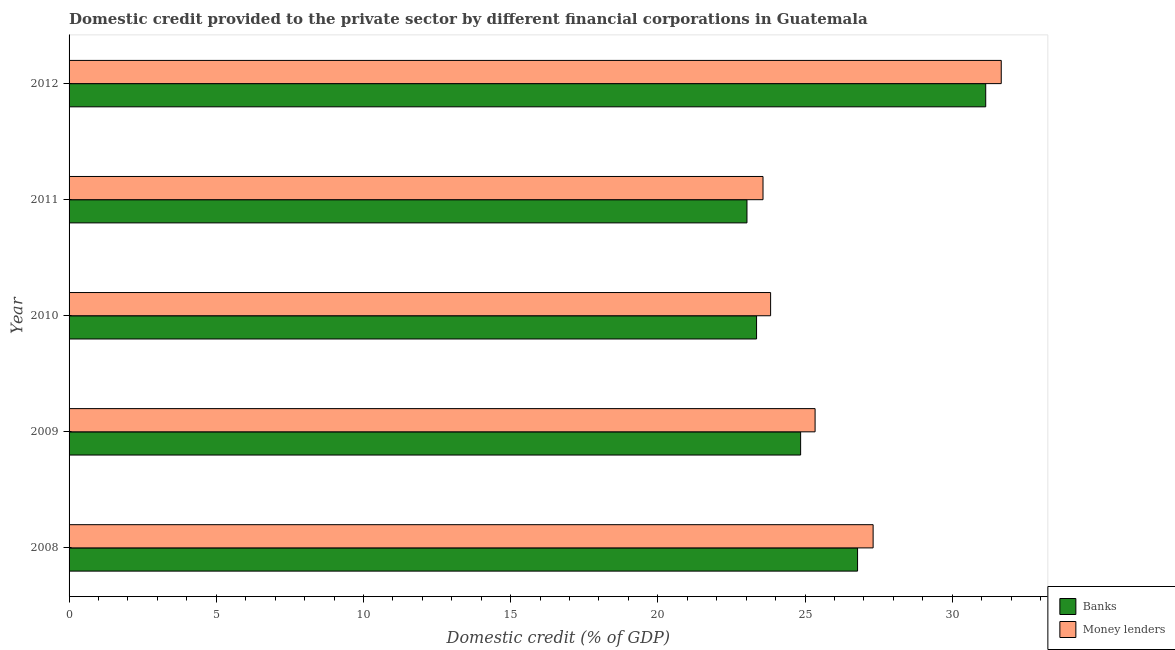How many different coloured bars are there?
Offer a terse response. 2. How many groups of bars are there?
Your answer should be very brief. 5. How many bars are there on the 1st tick from the bottom?
Your answer should be very brief. 2. What is the label of the 2nd group of bars from the top?
Your answer should be very brief. 2011. What is the domestic credit provided by banks in 2009?
Your answer should be very brief. 24.85. Across all years, what is the maximum domestic credit provided by banks?
Keep it short and to the point. 31.14. Across all years, what is the minimum domestic credit provided by money lenders?
Provide a short and direct response. 23.57. What is the total domestic credit provided by money lenders in the graph?
Your answer should be very brief. 131.72. What is the difference between the domestic credit provided by money lenders in 2011 and that in 2012?
Make the answer very short. -8.09. What is the difference between the domestic credit provided by banks in 2012 and the domestic credit provided by money lenders in 2009?
Provide a short and direct response. 5.8. What is the average domestic credit provided by banks per year?
Your response must be concise. 25.83. In the year 2009, what is the difference between the domestic credit provided by money lenders and domestic credit provided by banks?
Offer a very short reply. 0.49. In how many years, is the domestic credit provided by banks greater than 20 %?
Ensure brevity in your answer.  5. What is the ratio of the domestic credit provided by banks in 2008 to that in 2010?
Give a very brief answer. 1.15. What is the difference between the highest and the second highest domestic credit provided by banks?
Provide a succinct answer. 4.35. What is the difference between the highest and the lowest domestic credit provided by banks?
Your answer should be very brief. 8.11. What does the 1st bar from the top in 2011 represents?
Make the answer very short. Money lenders. What does the 2nd bar from the bottom in 2008 represents?
Make the answer very short. Money lenders. Are all the bars in the graph horizontal?
Ensure brevity in your answer.  Yes. Are the values on the major ticks of X-axis written in scientific E-notation?
Your response must be concise. No. Does the graph contain grids?
Offer a very short reply. No. Where does the legend appear in the graph?
Ensure brevity in your answer.  Bottom right. How are the legend labels stacked?
Ensure brevity in your answer.  Vertical. What is the title of the graph?
Your answer should be compact. Domestic credit provided to the private sector by different financial corporations in Guatemala. Does "GDP at market prices" appear as one of the legend labels in the graph?
Offer a very short reply. No. What is the label or title of the X-axis?
Your answer should be very brief. Domestic credit (% of GDP). What is the label or title of the Y-axis?
Provide a succinct answer. Year. What is the Domestic credit (% of GDP) of Banks in 2008?
Your response must be concise. 26.78. What is the Domestic credit (% of GDP) in Money lenders in 2008?
Provide a succinct answer. 27.31. What is the Domestic credit (% of GDP) in Banks in 2009?
Your response must be concise. 24.85. What is the Domestic credit (% of GDP) of Money lenders in 2009?
Provide a succinct answer. 25.34. What is the Domestic credit (% of GDP) in Banks in 2010?
Keep it short and to the point. 23.35. What is the Domestic credit (% of GDP) in Money lenders in 2010?
Your response must be concise. 23.83. What is the Domestic credit (% of GDP) in Banks in 2011?
Provide a short and direct response. 23.03. What is the Domestic credit (% of GDP) of Money lenders in 2011?
Keep it short and to the point. 23.57. What is the Domestic credit (% of GDP) of Banks in 2012?
Provide a short and direct response. 31.14. What is the Domestic credit (% of GDP) in Money lenders in 2012?
Provide a short and direct response. 31.66. Across all years, what is the maximum Domestic credit (% of GDP) of Banks?
Offer a terse response. 31.14. Across all years, what is the maximum Domestic credit (% of GDP) in Money lenders?
Ensure brevity in your answer.  31.66. Across all years, what is the minimum Domestic credit (% of GDP) in Banks?
Make the answer very short. 23.03. Across all years, what is the minimum Domestic credit (% of GDP) in Money lenders?
Ensure brevity in your answer.  23.57. What is the total Domestic credit (% of GDP) of Banks in the graph?
Provide a succinct answer. 129.15. What is the total Domestic credit (% of GDP) in Money lenders in the graph?
Provide a succinct answer. 131.72. What is the difference between the Domestic credit (% of GDP) in Banks in 2008 and that in 2009?
Ensure brevity in your answer.  1.93. What is the difference between the Domestic credit (% of GDP) of Money lenders in 2008 and that in 2009?
Your answer should be compact. 1.97. What is the difference between the Domestic credit (% of GDP) in Banks in 2008 and that in 2010?
Provide a succinct answer. 3.43. What is the difference between the Domestic credit (% of GDP) of Money lenders in 2008 and that in 2010?
Provide a succinct answer. 3.48. What is the difference between the Domestic credit (% of GDP) of Banks in 2008 and that in 2011?
Your response must be concise. 3.76. What is the difference between the Domestic credit (% of GDP) of Money lenders in 2008 and that in 2011?
Offer a very short reply. 3.74. What is the difference between the Domestic credit (% of GDP) in Banks in 2008 and that in 2012?
Provide a succinct answer. -4.35. What is the difference between the Domestic credit (% of GDP) in Money lenders in 2008 and that in 2012?
Keep it short and to the point. -4.35. What is the difference between the Domestic credit (% of GDP) of Banks in 2009 and that in 2010?
Offer a terse response. 1.5. What is the difference between the Domestic credit (% of GDP) of Money lenders in 2009 and that in 2010?
Offer a terse response. 1.51. What is the difference between the Domestic credit (% of GDP) of Banks in 2009 and that in 2011?
Your response must be concise. 1.82. What is the difference between the Domestic credit (% of GDP) of Money lenders in 2009 and that in 2011?
Provide a short and direct response. 1.77. What is the difference between the Domestic credit (% of GDP) of Banks in 2009 and that in 2012?
Offer a terse response. -6.29. What is the difference between the Domestic credit (% of GDP) in Money lenders in 2009 and that in 2012?
Your response must be concise. -6.32. What is the difference between the Domestic credit (% of GDP) in Banks in 2010 and that in 2011?
Provide a succinct answer. 0.33. What is the difference between the Domestic credit (% of GDP) of Money lenders in 2010 and that in 2011?
Provide a short and direct response. 0.26. What is the difference between the Domestic credit (% of GDP) of Banks in 2010 and that in 2012?
Your answer should be very brief. -7.78. What is the difference between the Domestic credit (% of GDP) of Money lenders in 2010 and that in 2012?
Offer a terse response. -7.83. What is the difference between the Domestic credit (% of GDP) in Banks in 2011 and that in 2012?
Ensure brevity in your answer.  -8.11. What is the difference between the Domestic credit (% of GDP) in Money lenders in 2011 and that in 2012?
Give a very brief answer. -8.09. What is the difference between the Domestic credit (% of GDP) in Banks in 2008 and the Domestic credit (% of GDP) in Money lenders in 2009?
Offer a very short reply. 1.44. What is the difference between the Domestic credit (% of GDP) of Banks in 2008 and the Domestic credit (% of GDP) of Money lenders in 2010?
Ensure brevity in your answer.  2.95. What is the difference between the Domestic credit (% of GDP) in Banks in 2008 and the Domestic credit (% of GDP) in Money lenders in 2011?
Offer a terse response. 3.21. What is the difference between the Domestic credit (% of GDP) of Banks in 2008 and the Domestic credit (% of GDP) of Money lenders in 2012?
Give a very brief answer. -4.88. What is the difference between the Domestic credit (% of GDP) of Banks in 2009 and the Domestic credit (% of GDP) of Money lenders in 2010?
Offer a terse response. 1.02. What is the difference between the Domestic credit (% of GDP) of Banks in 2009 and the Domestic credit (% of GDP) of Money lenders in 2011?
Keep it short and to the point. 1.28. What is the difference between the Domestic credit (% of GDP) in Banks in 2009 and the Domestic credit (% of GDP) in Money lenders in 2012?
Offer a very short reply. -6.81. What is the difference between the Domestic credit (% of GDP) of Banks in 2010 and the Domestic credit (% of GDP) of Money lenders in 2011?
Make the answer very short. -0.22. What is the difference between the Domestic credit (% of GDP) in Banks in 2010 and the Domestic credit (% of GDP) in Money lenders in 2012?
Offer a terse response. -8.31. What is the difference between the Domestic credit (% of GDP) in Banks in 2011 and the Domestic credit (% of GDP) in Money lenders in 2012?
Provide a short and direct response. -8.64. What is the average Domestic credit (% of GDP) in Banks per year?
Offer a terse response. 25.83. What is the average Domestic credit (% of GDP) in Money lenders per year?
Make the answer very short. 26.34. In the year 2008, what is the difference between the Domestic credit (% of GDP) of Banks and Domestic credit (% of GDP) of Money lenders?
Give a very brief answer. -0.53. In the year 2009, what is the difference between the Domestic credit (% of GDP) of Banks and Domestic credit (% of GDP) of Money lenders?
Provide a short and direct response. -0.49. In the year 2010, what is the difference between the Domestic credit (% of GDP) in Banks and Domestic credit (% of GDP) in Money lenders?
Offer a terse response. -0.48. In the year 2011, what is the difference between the Domestic credit (% of GDP) in Banks and Domestic credit (% of GDP) in Money lenders?
Offer a very short reply. -0.54. In the year 2012, what is the difference between the Domestic credit (% of GDP) in Banks and Domestic credit (% of GDP) in Money lenders?
Your response must be concise. -0.53. What is the ratio of the Domestic credit (% of GDP) in Banks in 2008 to that in 2009?
Your answer should be compact. 1.08. What is the ratio of the Domestic credit (% of GDP) of Money lenders in 2008 to that in 2009?
Your answer should be compact. 1.08. What is the ratio of the Domestic credit (% of GDP) of Banks in 2008 to that in 2010?
Ensure brevity in your answer.  1.15. What is the ratio of the Domestic credit (% of GDP) in Money lenders in 2008 to that in 2010?
Give a very brief answer. 1.15. What is the ratio of the Domestic credit (% of GDP) in Banks in 2008 to that in 2011?
Your answer should be compact. 1.16. What is the ratio of the Domestic credit (% of GDP) in Money lenders in 2008 to that in 2011?
Offer a very short reply. 1.16. What is the ratio of the Domestic credit (% of GDP) in Banks in 2008 to that in 2012?
Provide a short and direct response. 0.86. What is the ratio of the Domestic credit (% of GDP) of Money lenders in 2008 to that in 2012?
Ensure brevity in your answer.  0.86. What is the ratio of the Domestic credit (% of GDP) in Banks in 2009 to that in 2010?
Keep it short and to the point. 1.06. What is the ratio of the Domestic credit (% of GDP) in Money lenders in 2009 to that in 2010?
Give a very brief answer. 1.06. What is the ratio of the Domestic credit (% of GDP) of Banks in 2009 to that in 2011?
Give a very brief answer. 1.08. What is the ratio of the Domestic credit (% of GDP) in Money lenders in 2009 to that in 2011?
Ensure brevity in your answer.  1.08. What is the ratio of the Domestic credit (% of GDP) in Banks in 2009 to that in 2012?
Keep it short and to the point. 0.8. What is the ratio of the Domestic credit (% of GDP) in Money lenders in 2009 to that in 2012?
Give a very brief answer. 0.8. What is the ratio of the Domestic credit (% of GDP) in Banks in 2010 to that in 2011?
Keep it short and to the point. 1.01. What is the ratio of the Domestic credit (% of GDP) of Money lenders in 2010 to that in 2011?
Provide a short and direct response. 1.01. What is the ratio of the Domestic credit (% of GDP) in Money lenders in 2010 to that in 2012?
Your response must be concise. 0.75. What is the ratio of the Domestic credit (% of GDP) in Banks in 2011 to that in 2012?
Offer a terse response. 0.74. What is the ratio of the Domestic credit (% of GDP) in Money lenders in 2011 to that in 2012?
Your answer should be very brief. 0.74. What is the difference between the highest and the second highest Domestic credit (% of GDP) of Banks?
Give a very brief answer. 4.35. What is the difference between the highest and the second highest Domestic credit (% of GDP) of Money lenders?
Give a very brief answer. 4.35. What is the difference between the highest and the lowest Domestic credit (% of GDP) in Banks?
Keep it short and to the point. 8.11. What is the difference between the highest and the lowest Domestic credit (% of GDP) in Money lenders?
Your answer should be compact. 8.09. 